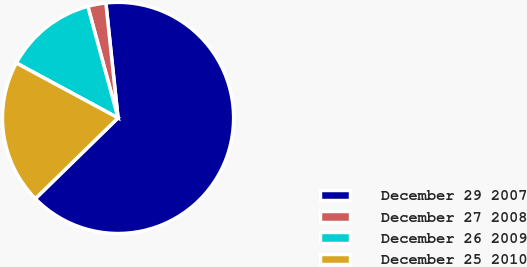Convert chart. <chart><loc_0><loc_0><loc_500><loc_500><pie_chart><fcel>December 29 2007<fcel>December 27 2008<fcel>December 26 2009<fcel>December 25 2010<nl><fcel>64.37%<fcel>2.53%<fcel>12.91%<fcel>20.19%<nl></chart> 